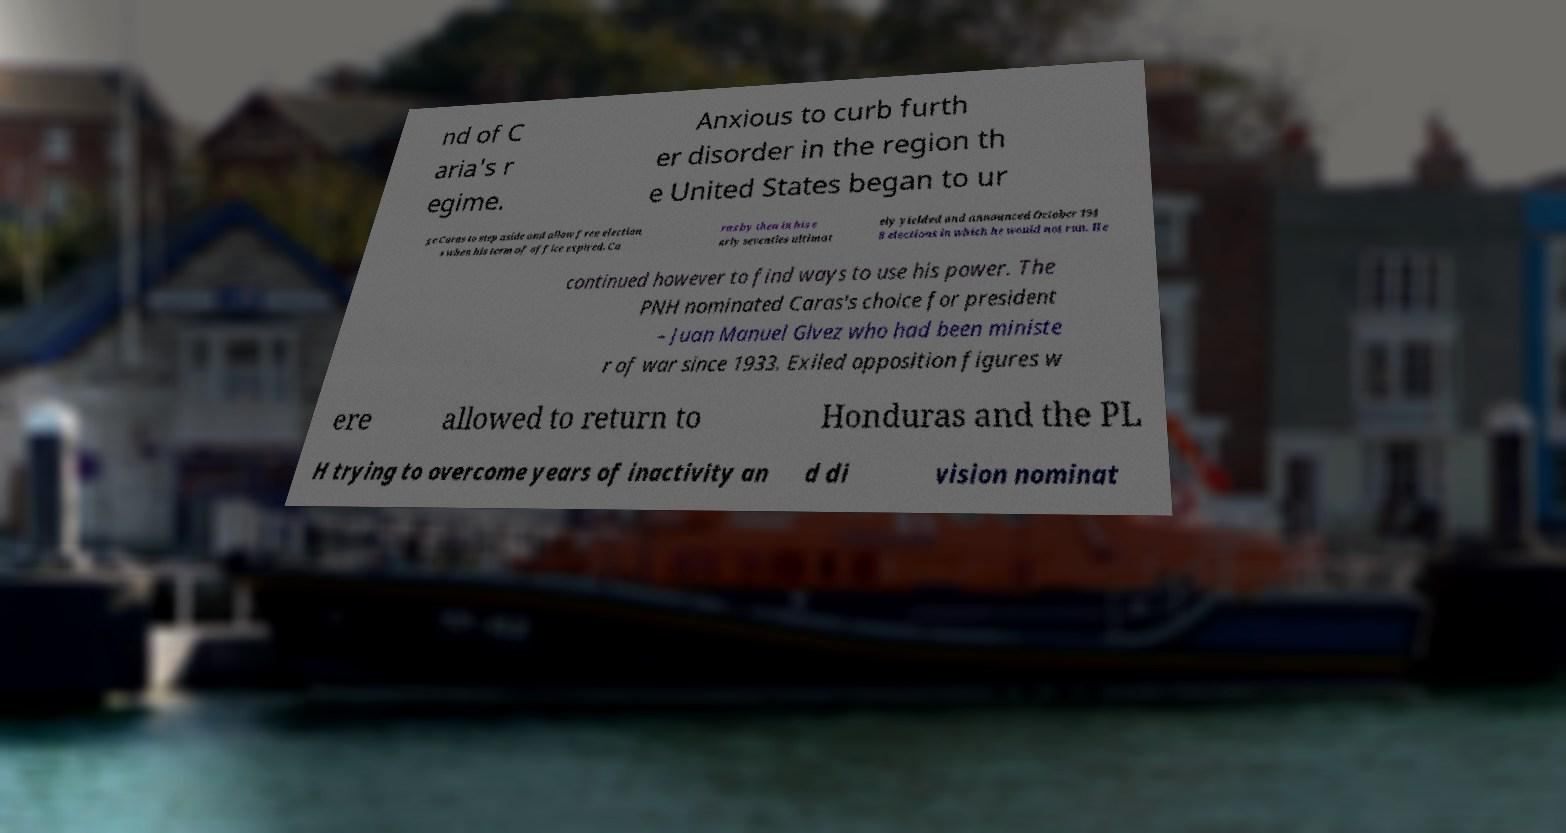Can you accurately transcribe the text from the provided image for me? nd of C aria's r egime. Anxious to curb furth er disorder in the region th e United States began to ur ge Caras to step aside and allow free election s when his term of office expired. Ca ras by then in his e arly seventies ultimat ely yielded and announced October 194 8 elections in which he would not run. He continued however to find ways to use his power. The PNH nominated Caras's choice for president – Juan Manuel Glvez who had been ministe r of war since 1933. Exiled opposition figures w ere allowed to return to Honduras and the PL H trying to overcome years of inactivity an d di vision nominat 